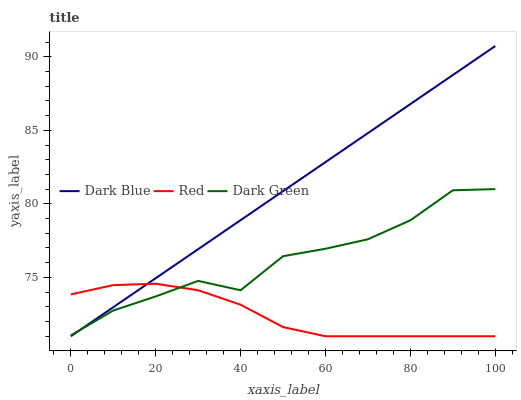Does Red have the minimum area under the curve?
Answer yes or no. Yes. Does Dark Blue have the maximum area under the curve?
Answer yes or no. Yes. Does Dark Green have the minimum area under the curve?
Answer yes or no. No. Does Dark Green have the maximum area under the curve?
Answer yes or no. No. Is Dark Blue the smoothest?
Answer yes or no. Yes. Is Dark Green the roughest?
Answer yes or no. Yes. Is Red the smoothest?
Answer yes or no. No. Is Red the roughest?
Answer yes or no. No. Does Dark Blue have the lowest value?
Answer yes or no. Yes. Does Dark Green have the lowest value?
Answer yes or no. No. Does Dark Blue have the highest value?
Answer yes or no. Yes. Does Dark Green have the highest value?
Answer yes or no. No. Does Red intersect Dark Blue?
Answer yes or no. Yes. Is Red less than Dark Blue?
Answer yes or no. No. Is Red greater than Dark Blue?
Answer yes or no. No. 